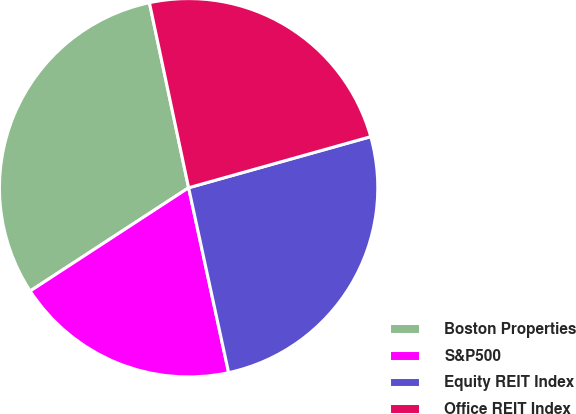Convert chart to OTSL. <chart><loc_0><loc_0><loc_500><loc_500><pie_chart><fcel>Boston Properties<fcel>S&P500<fcel>Equity REIT Index<fcel>Office REIT Index<nl><fcel>30.87%<fcel>19.2%<fcel>25.96%<fcel>23.97%<nl></chart> 